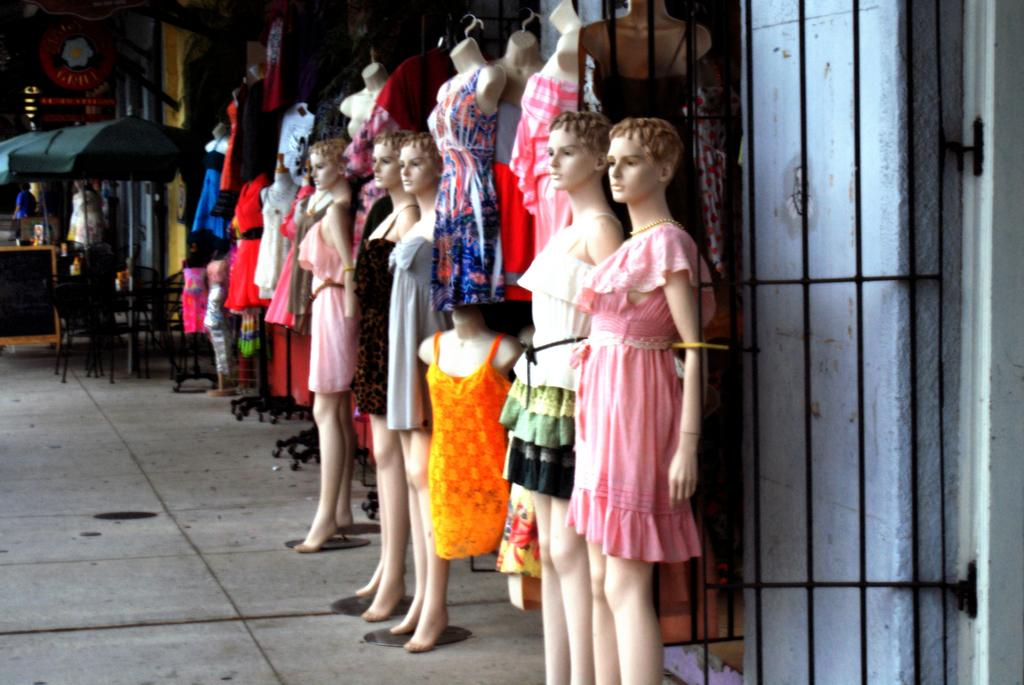What type of objects can be seen in the image? There are mannequins in the image. What can be found on the right side of the image? There is a grill on the right side of the image. What type of furniture is present in the image? There are chairs in the image. What is located at the back of the image? There is a board at the back of the image. Can you see any mice playing basketball in the image? No, there are no mice or basketball present in the image. 